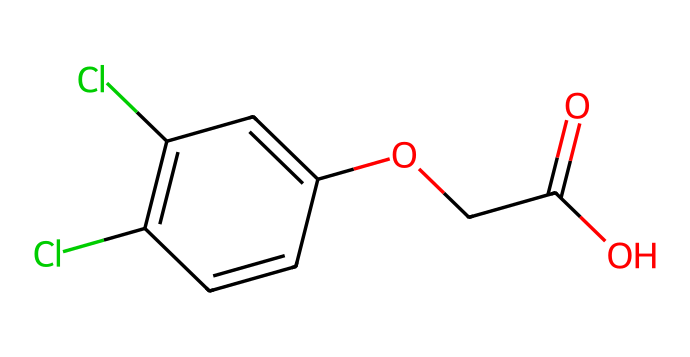What is the molecular formula of this herbicide? To determine the molecular formula, we count the number and types of atoms present in the structure. In the provided SMILES, we have C (carbon), H (hydrogen), Cl (chlorine), and O (oxygen) atoms. By analyzing the structure, we find there are 10 carbon atoms, 9 hydrogen atoms, 2 chlorine atoms, and 4 oxygen atoms, which gives us the molecular formula C10H9Cl2O4.
Answer: C10H9Cl2O4 How many chlorine atoms are present in the chemical structure? The chemical structure includes two chlorines, which can be identified from the "Cl" symbols in the SMILES. Each "Cl" represents one chlorine atom, and there are two occurrences.
Answer: 2 What type of functional group is represented by the "C(=O)O" part of the structure? The "C(=O)O" part indicates a carboxylic acid functional group. The "C(=O)" implies a carbon bonded to oxygen with a double bond, and "O" connected to that carbon shows an -OH group, characteristic of carboxylic acids.
Answer: carboxylic acid What effect does the presence of chlorine atoms have on the herbicide? Chlorine atoms typically enhance the herbicide's effectiveness by increasing its biological activity and stability in the environment. Their electronegativity alters how the herbicide interacts chemically with plant enzymes or receptors, making it a potent herbicide.
Answer: increase effectiveness Which part of the structure is primarily responsible for its herbicidal properties? The phenoxy group (indicated by the "C1=C" structure) is crucial for the herbicidal activity, as it mimics natural plant hormones and disrupts growth processes. This can be determined by the connectivity and position of the aromatic ring relative to the carboxylic acid, which plays a key role in its functionality as a herbicide.
Answer: phenoxy group 